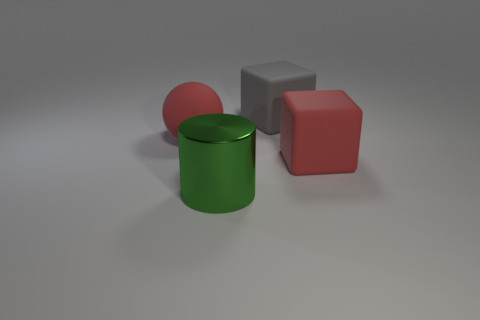Add 2 small yellow cylinders. How many objects exist? 6 Subtract all cylinders. How many objects are left? 3 Subtract 0 yellow spheres. How many objects are left? 4 Subtract all cyan metal cubes. Subtract all red balls. How many objects are left? 3 Add 1 big gray rubber blocks. How many big gray rubber blocks are left? 2 Add 3 tiny gray shiny cubes. How many tiny gray shiny cubes exist? 3 